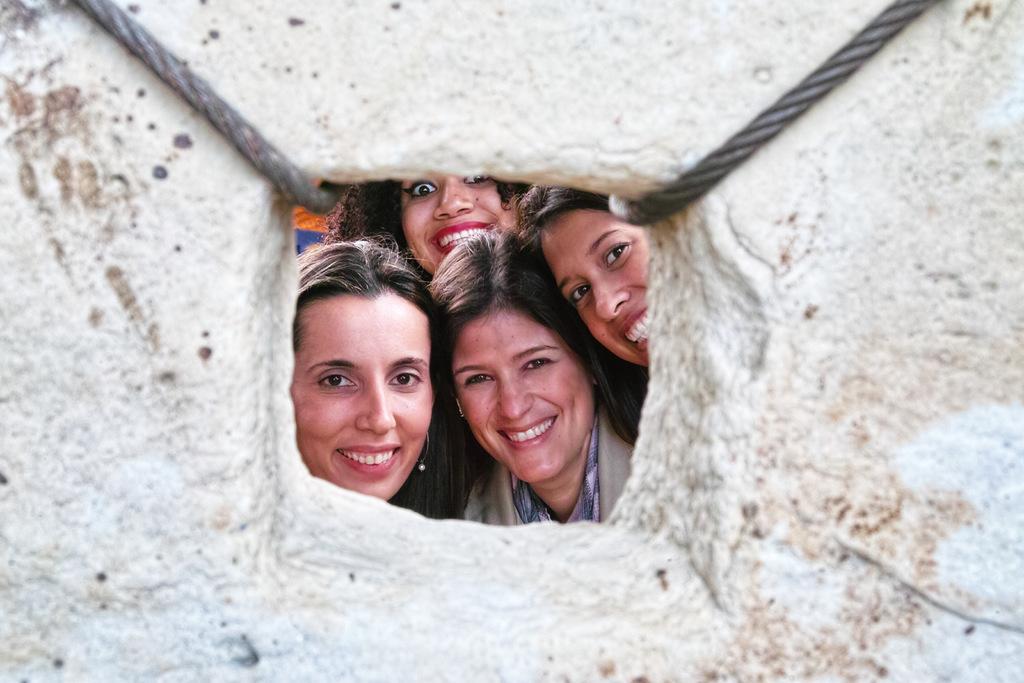Please provide a concise description of this image. In this picture we can see a stone, ropes and in the background we can see four women smiling. 